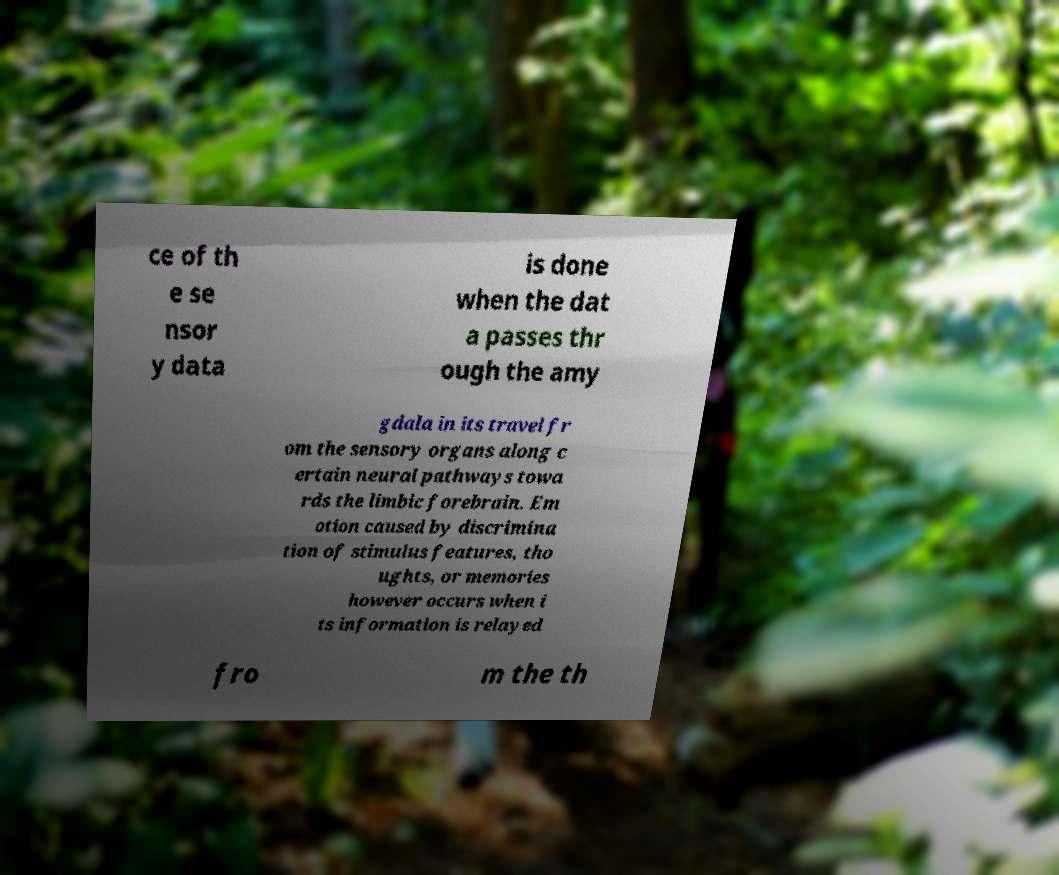Can you read and provide the text displayed in the image?This photo seems to have some interesting text. Can you extract and type it out for me? ce of th e se nsor y data is done when the dat a passes thr ough the amy gdala in its travel fr om the sensory organs along c ertain neural pathways towa rds the limbic forebrain. Em otion caused by discrimina tion of stimulus features, tho ughts, or memories however occurs when i ts information is relayed fro m the th 